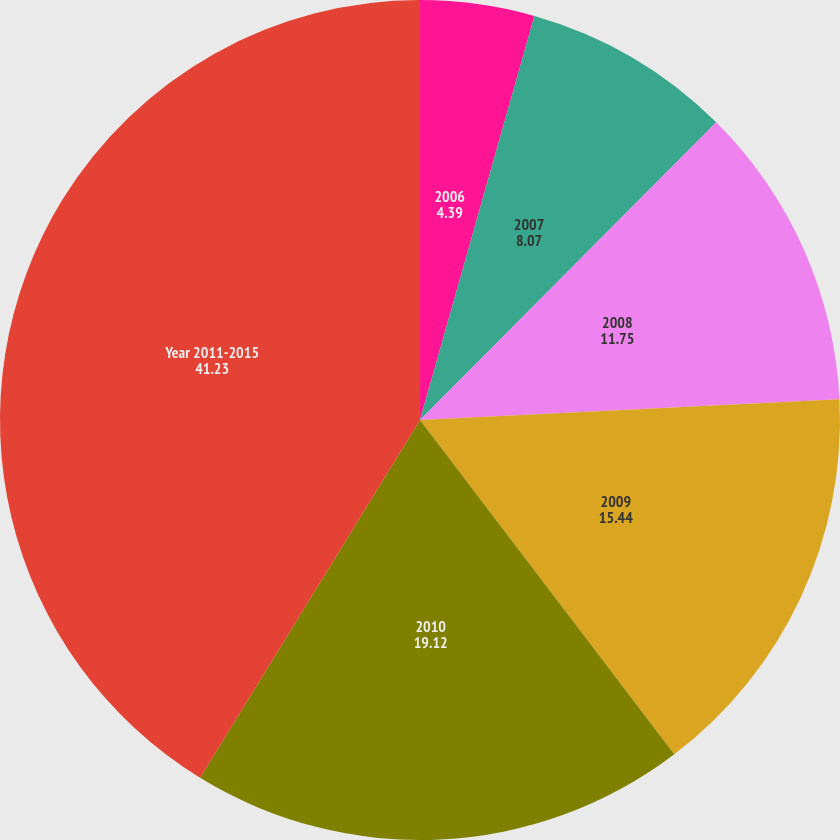Convert chart. <chart><loc_0><loc_0><loc_500><loc_500><pie_chart><fcel>2006<fcel>2007<fcel>2008<fcel>2009<fcel>2010<fcel>Year 2011-2015<nl><fcel>4.39%<fcel>8.07%<fcel>11.75%<fcel>15.44%<fcel>19.12%<fcel>41.23%<nl></chart> 